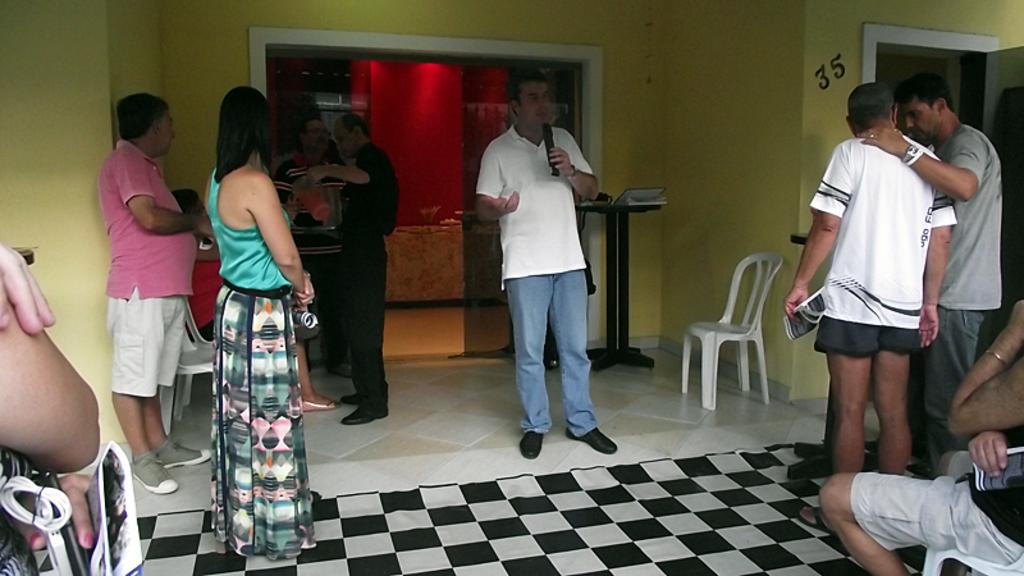What are the people in the image doing? Some people are standing, while others are sitting in the image. Can you describe the person holding a microphone? A: A person is holding a microphone, which suggests they might be speaking or performing. What type of furniture is visible in the image? Chairs are visible in the image. What is on the table in the image? There are objects on a table in the image. What is visible in the background of the image? There is a wall visible in the image. What type of crime is being committed in the image? There is no indication of any crime being committed in the image. How does the pollution affect the people in the image? There is no visible pollution in the image, so its effect on the people cannot be determined. 